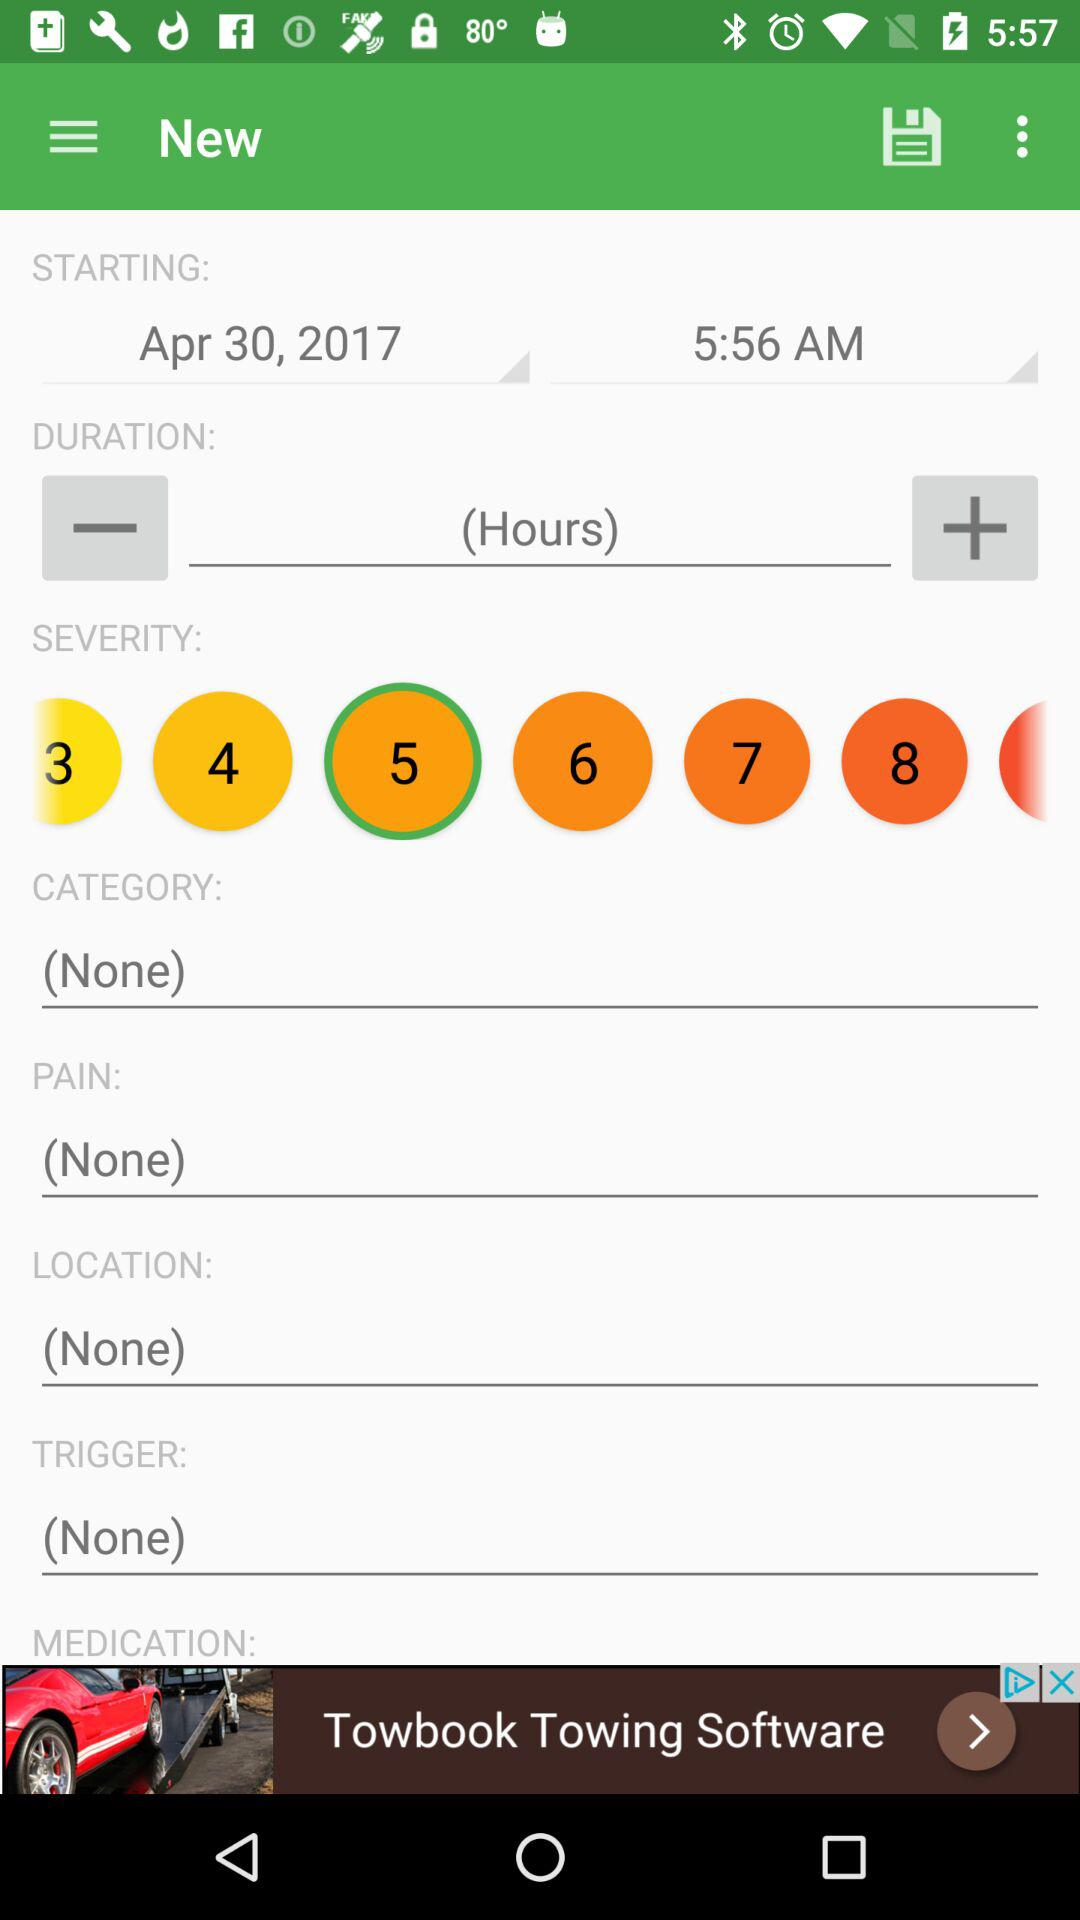What is the starting time? The starting time is 5:56 AM. 